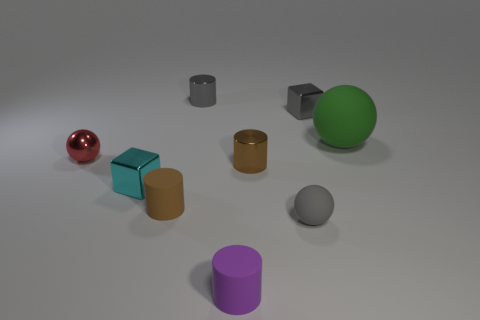What do the different colors of the objects suggest? The objects' varied colors could suggest diversity or be used to demonstrate color theory. The presence of primary and secondary colors illustrates the basis of color mixing, or it might simply be chosen for aesthetic appeal to make the image more visually engaging. How might the colors affect the mood or tone of the image? Colors have psychological effects and can evoke different emotions. The soft, muted background paired with the brightly colored objects creates a contrast that can be pleasing and calming, while also drawing the viewer's attention to the objects themselves. 